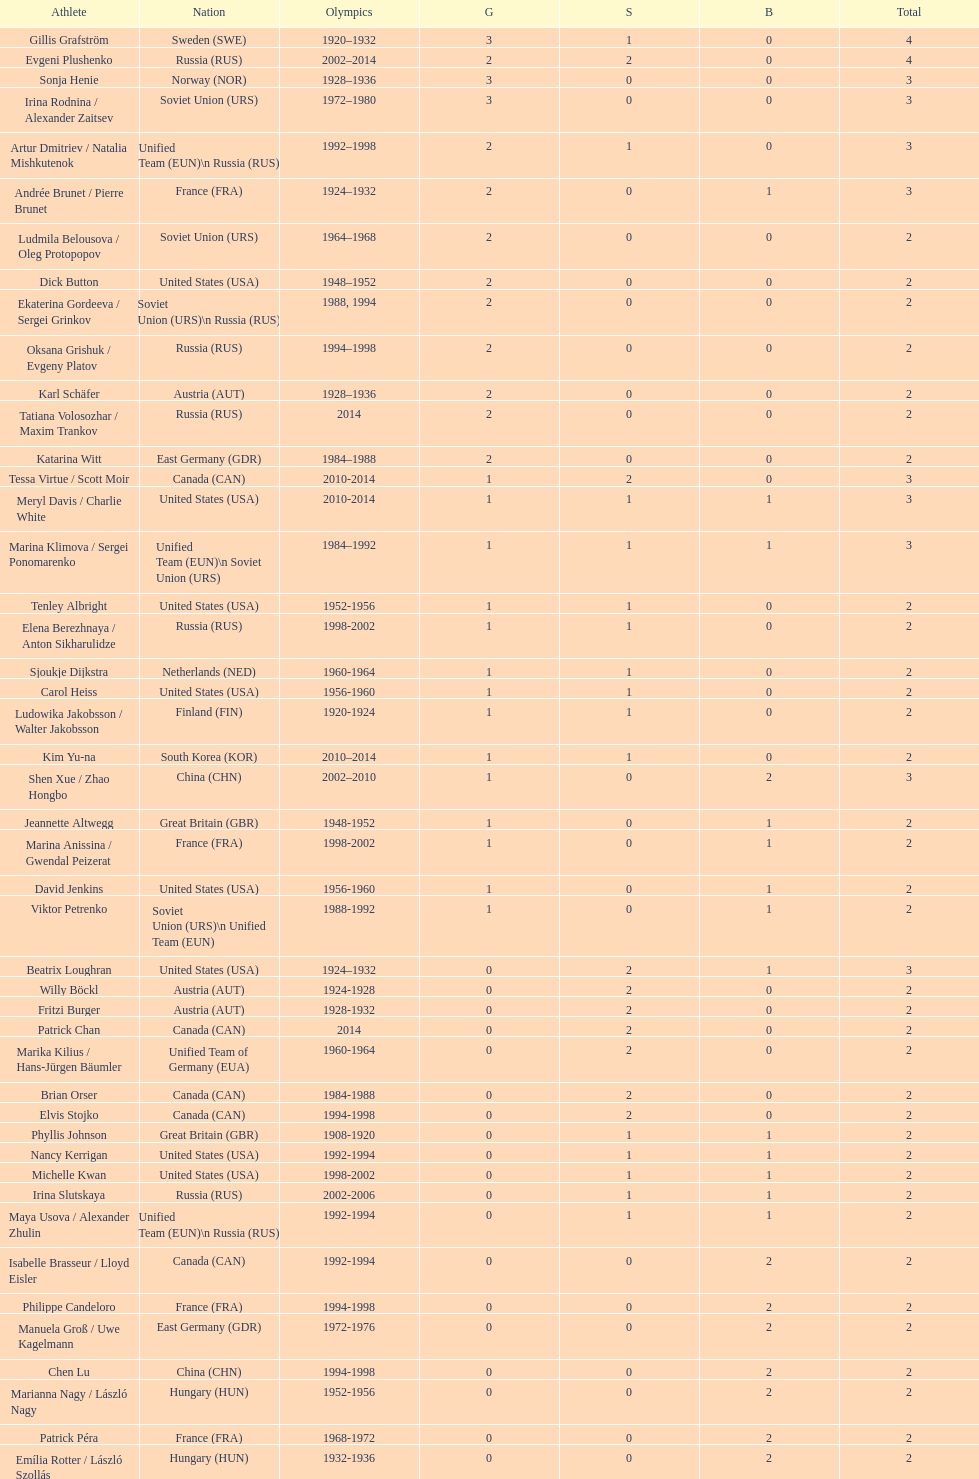Could you parse the entire table? {'header': ['Athlete', 'Nation', 'Olympics', 'G', 'S', 'B', 'Total'], 'rows': [['Gillis Grafström', 'Sweden\xa0(SWE)', '1920–1932', '3', '1', '0', '4'], ['Evgeni Plushenko', 'Russia\xa0(RUS)', '2002–2014', '2', '2', '0', '4'], ['Sonja Henie', 'Norway\xa0(NOR)', '1928–1936', '3', '0', '0', '3'], ['Irina Rodnina / Alexander Zaitsev', 'Soviet Union\xa0(URS)', '1972–1980', '3', '0', '0', '3'], ['Artur Dmitriev / Natalia Mishkutenok', 'Unified Team\xa0(EUN)\\n\xa0Russia\xa0(RUS)', '1992–1998', '2', '1', '0', '3'], ['Andrée Brunet / Pierre Brunet', 'France\xa0(FRA)', '1924–1932', '2', '0', '1', '3'], ['Ludmila Belousova / Oleg Protopopov', 'Soviet Union\xa0(URS)', '1964–1968', '2', '0', '0', '2'], ['Dick Button', 'United States\xa0(USA)', '1948–1952', '2', '0', '0', '2'], ['Ekaterina Gordeeva / Sergei Grinkov', 'Soviet Union\xa0(URS)\\n\xa0Russia\xa0(RUS)', '1988, 1994', '2', '0', '0', '2'], ['Oksana Grishuk / Evgeny Platov', 'Russia\xa0(RUS)', '1994–1998', '2', '0', '0', '2'], ['Karl Schäfer', 'Austria\xa0(AUT)', '1928–1936', '2', '0', '0', '2'], ['Tatiana Volosozhar / Maxim Trankov', 'Russia\xa0(RUS)', '2014', '2', '0', '0', '2'], ['Katarina Witt', 'East Germany\xa0(GDR)', '1984–1988', '2', '0', '0', '2'], ['Tessa Virtue / Scott Moir', 'Canada\xa0(CAN)', '2010-2014', '1', '2', '0', '3'], ['Meryl Davis / Charlie White', 'United States\xa0(USA)', '2010-2014', '1', '1', '1', '3'], ['Marina Klimova / Sergei Ponomarenko', 'Unified Team\xa0(EUN)\\n\xa0Soviet Union\xa0(URS)', '1984–1992', '1', '1', '1', '3'], ['Tenley Albright', 'United States\xa0(USA)', '1952-1956', '1', '1', '0', '2'], ['Elena Berezhnaya / Anton Sikharulidze', 'Russia\xa0(RUS)', '1998-2002', '1', '1', '0', '2'], ['Sjoukje Dijkstra', 'Netherlands\xa0(NED)', '1960-1964', '1', '1', '0', '2'], ['Carol Heiss', 'United States\xa0(USA)', '1956-1960', '1', '1', '0', '2'], ['Ludowika Jakobsson / Walter Jakobsson', 'Finland\xa0(FIN)', '1920-1924', '1', '1', '0', '2'], ['Kim Yu-na', 'South Korea\xa0(KOR)', '2010–2014', '1', '1', '0', '2'], ['Shen Xue / Zhao Hongbo', 'China\xa0(CHN)', '2002–2010', '1', '0', '2', '3'], ['Jeannette Altwegg', 'Great Britain\xa0(GBR)', '1948-1952', '1', '0', '1', '2'], ['Marina Anissina / Gwendal Peizerat', 'France\xa0(FRA)', '1998-2002', '1', '0', '1', '2'], ['David Jenkins', 'United States\xa0(USA)', '1956-1960', '1', '0', '1', '2'], ['Viktor Petrenko', 'Soviet Union\xa0(URS)\\n\xa0Unified Team\xa0(EUN)', '1988-1992', '1', '0', '1', '2'], ['Beatrix Loughran', 'United States\xa0(USA)', '1924–1932', '0', '2', '1', '3'], ['Willy Böckl', 'Austria\xa0(AUT)', '1924-1928', '0', '2', '0', '2'], ['Fritzi Burger', 'Austria\xa0(AUT)', '1928-1932', '0', '2', '0', '2'], ['Patrick Chan', 'Canada\xa0(CAN)', '2014', '0', '2', '0', '2'], ['Marika Kilius / Hans-Jürgen Bäumler', 'Unified Team of Germany\xa0(EUA)', '1960-1964', '0', '2', '0', '2'], ['Brian Orser', 'Canada\xa0(CAN)', '1984-1988', '0', '2', '0', '2'], ['Elvis Stojko', 'Canada\xa0(CAN)', '1994-1998', '0', '2', '0', '2'], ['Phyllis Johnson', 'Great Britain\xa0(GBR)', '1908-1920', '0', '1', '1', '2'], ['Nancy Kerrigan', 'United States\xa0(USA)', '1992-1994', '0', '1', '1', '2'], ['Michelle Kwan', 'United States\xa0(USA)', '1998-2002', '0', '1', '1', '2'], ['Irina Slutskaya', 'Russia\xa0(RUS)', '2002-2006', '0', '1', '1', '2'], ['Maya Usova / Alexander Zhulin', 'Unified Team\xa0(EUN)\\n\xa0Russia\xa0(RUS)', '1992-1994', '0', '1', '1', '2'], ['Isabelle Brasseur / Lloyd Eisler', 'Canada\xa0(CAN)', '1992-1994', '0', '0', '2', '2'], ['Philippe Candeloro', 'France\xa0(FRA)', '1994-1998', '0', '0', '2', '2'], ['Manuela Groß / Uwe Kagelmann', 'East Germany\xa0(GDR)', '1972-1976', '0', '0', '2', '2'], ['Chen Lu', 'China\xa0(CHN)', '1994-1998', '0', '0', '2', '2'], ['Marianna Nagy / László Nagy', 'Hungary\xa0(HUN)', '1952-1956', '0', '0', '2', '2'], ['Patrick Péra', 'France\xa0(FRA)', '1968-1972', '0', '0', '2', '2'], ['Emília Rotter / László Szollás', 'Hungary\xa0(HUN)', '1932-1936', '0', '0', '2', '2'], ['Aliona Savchenko / Robin Szolkowy', 'Germany\xa0(GER)', '2010-2014', '0', '0', '2', '2']]} What's the cumulative count of medals the united states has achieved in women's figure skating? 16. 